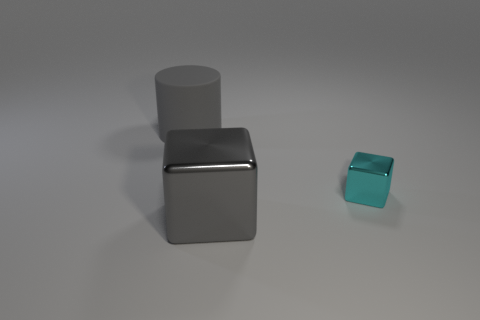Is there anything else that is the same size as the cyan shiny thing?
Your response must be concise. No. Is there any other thing that is made of the same material as the big cylinder?
Give a very brief answer. No. There is a cube that is the same color as the large cylinder; what is its material?
Your answer should be compact. Metal. Is there a rubber block that has the same color as the cylinder?
Give a very brief answer. No. The rubber thing that is the same size as the gray metallic cube is what shape?
Your answer should be compact. Cylinder. What number of gray things are either matte cylinders or balls?
Give a very brief answer. 1. What number of gray cubes have the same size as the rubber cylinder?
Your response must be concise. 1. There is a big rubber object that is the same color as the large cube; what shape is it?
Provide a short and direct response. Cylinder. What number of objects are either tiny blocks or metal blocks that are to the left of the tiny cyan block?
Ensure brevity in your answer.  2. Do the metal thing that is to the right of the gray cube and the cylinder that is behind the large gray metal cube have the same size?
Make the answer very short. No. 